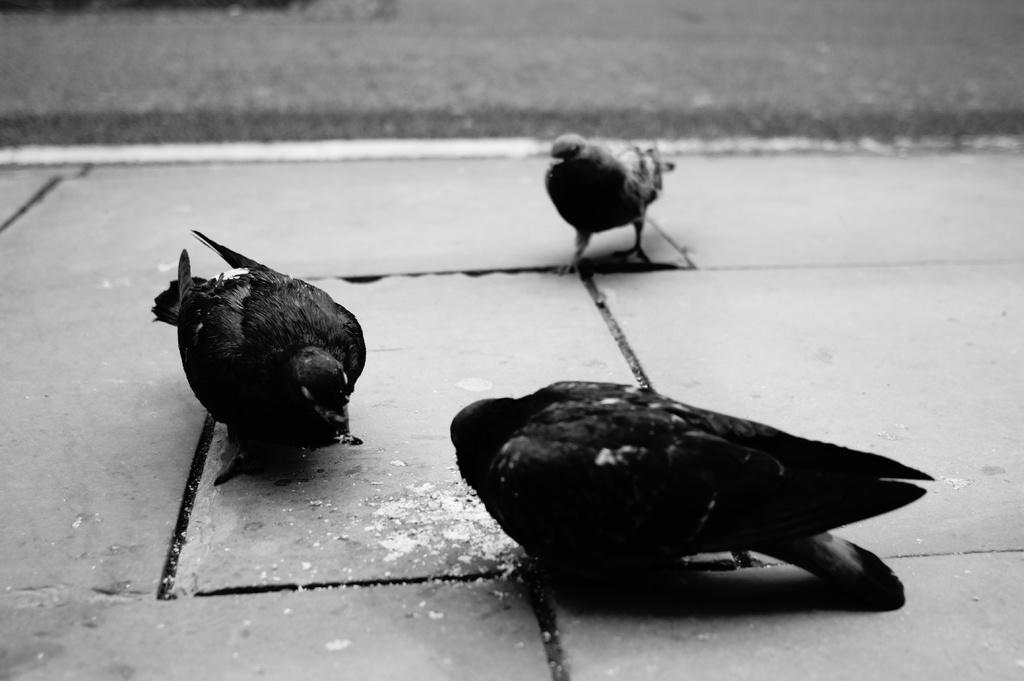What type of animals can be seen in the image? There are birds in the image. What colors are the birds? The birds are black and ash in color. Where are the birds located in the image? The birds are on the sidewalk. What can be seen in the background of the image? There is a road visible in the background of the image. How do the birds kiss each other in the image? There is no indication in the image that the birds are kissing each other, as they are simply standing on the sidewalk. 